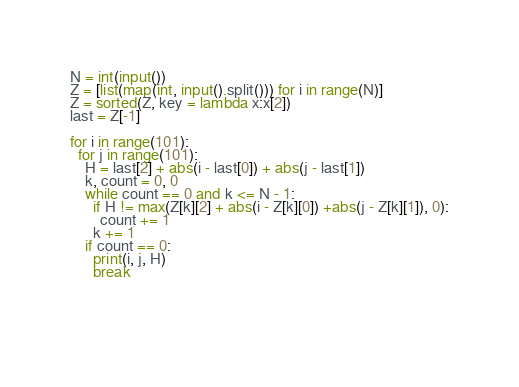Convert code to text. <code><loc_0><loc_0><loc_500><loc_500><_Python_>N = int(input())
Z = [list(map(int, input().split())) for i in range(N)]
Z = sorted(Z, key = lambda x:x[2])
last = Z[-1]

for i in range(101):
  for j in range(101):
    H = last[2] + abs(i - last[0]) + abs(j - last[1])
    k, count = 0, 0 
    while count == 0 and k <= N - 1:
      if H != max(Z[k][2] + abs(i - Z[k][0]) +abs(j - Z[k][1]), 0):
        count += 1
      k += 1
    if count == 0:
      print(i, j, H)
      break

  
        </code> 